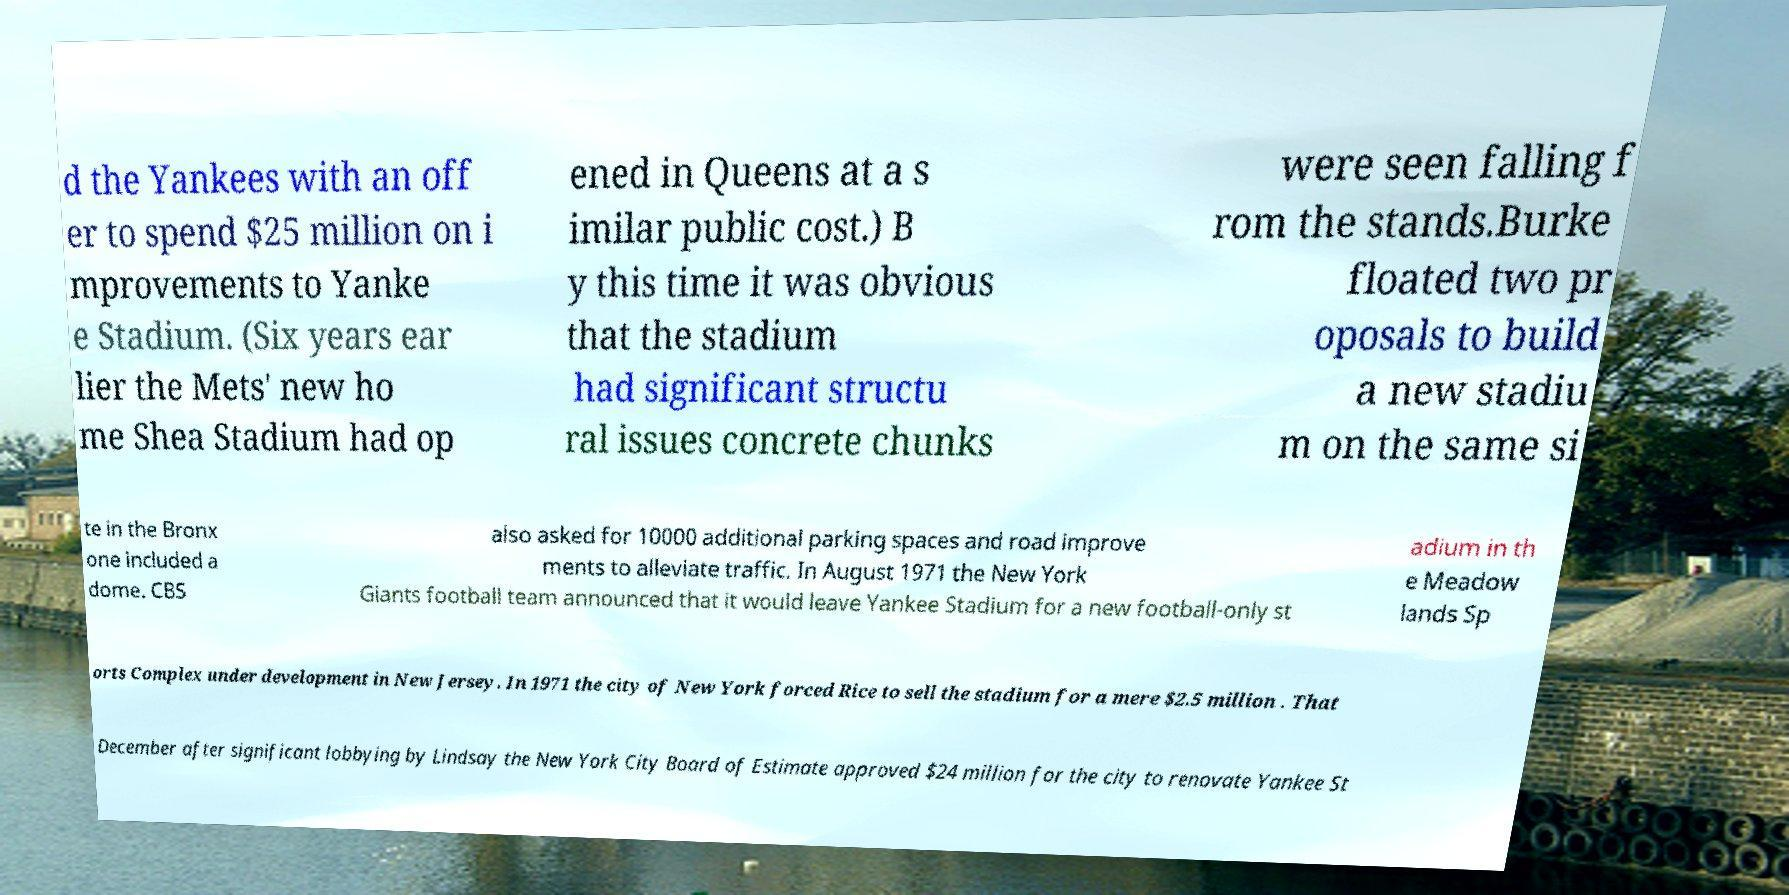Could you assist in decoding the text presented in this image and type it out clearly? d the Yankees with an off er to spend $25 million on i mprovements to Yanke e Stadium. (Six years ear lier the Mets' new ho me Shea Stadium had op ened in Queens at a s imilar public cost.) B y this time it was obvious that the stadium had significant structu ral issues concrete chunks were seen falling f rom the stands.Burke floated two pr oposals to build a new stadiu m on the same si te in the Bronx one included a dome. CBS also asked for 10000 additional parking spaces and road improve ments to alleviate traffic. In August 1971 the New York Giants football team announced that it would leave Yankee Stadium for a new football-only st adium in th e Meadow lands Sp orts Complex under development in New Jersey. In 1971 the city of New York forced Rice to sell the stadium for a mere $2.5 million . That December after significant lobbying by Lindsay the New York City Board of Estimate approved $24 million for the city to renovate Yankee St 